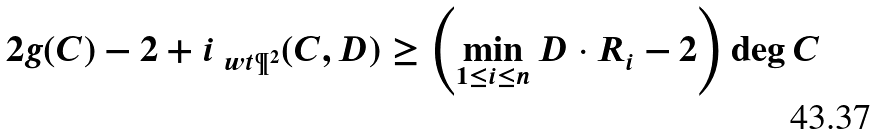<formula> <loc_0><loc_0><loc_500><loc_500>2 g ( C ) - 2 + i _ { \ w t { \P } ^ { 2 } } ( C , D ) \geq \left ( \min _ { 1 \leq i \leq n } D \cdot R _ { i } - 2 \right ) \deg C</formula> 